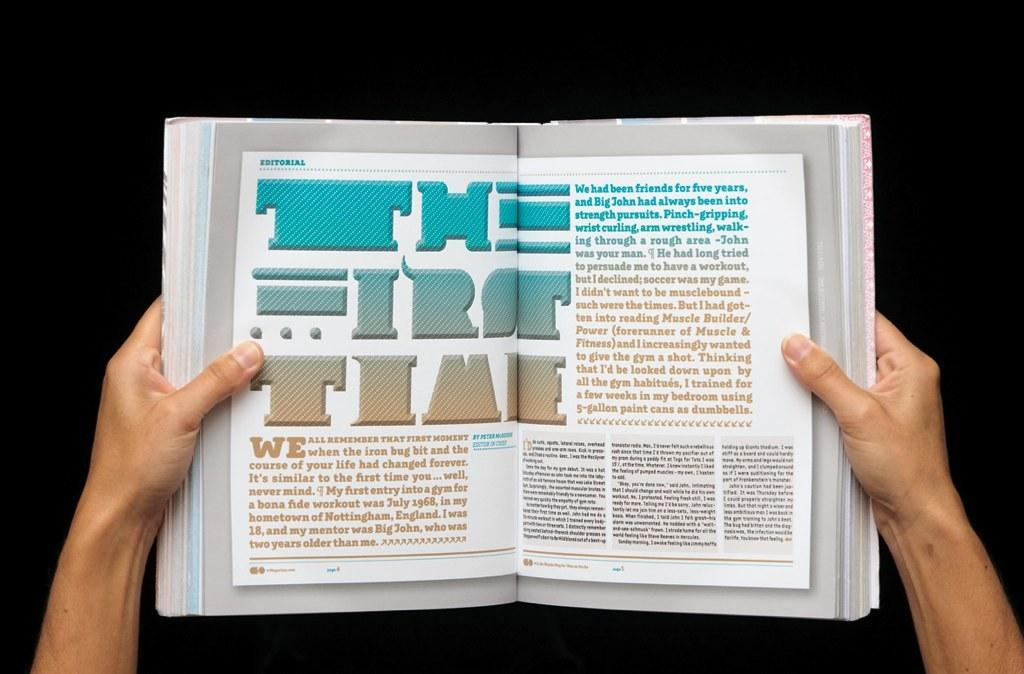<image>
Describe the image concisely. A book is opened and the first word at the top left is Editorial. 